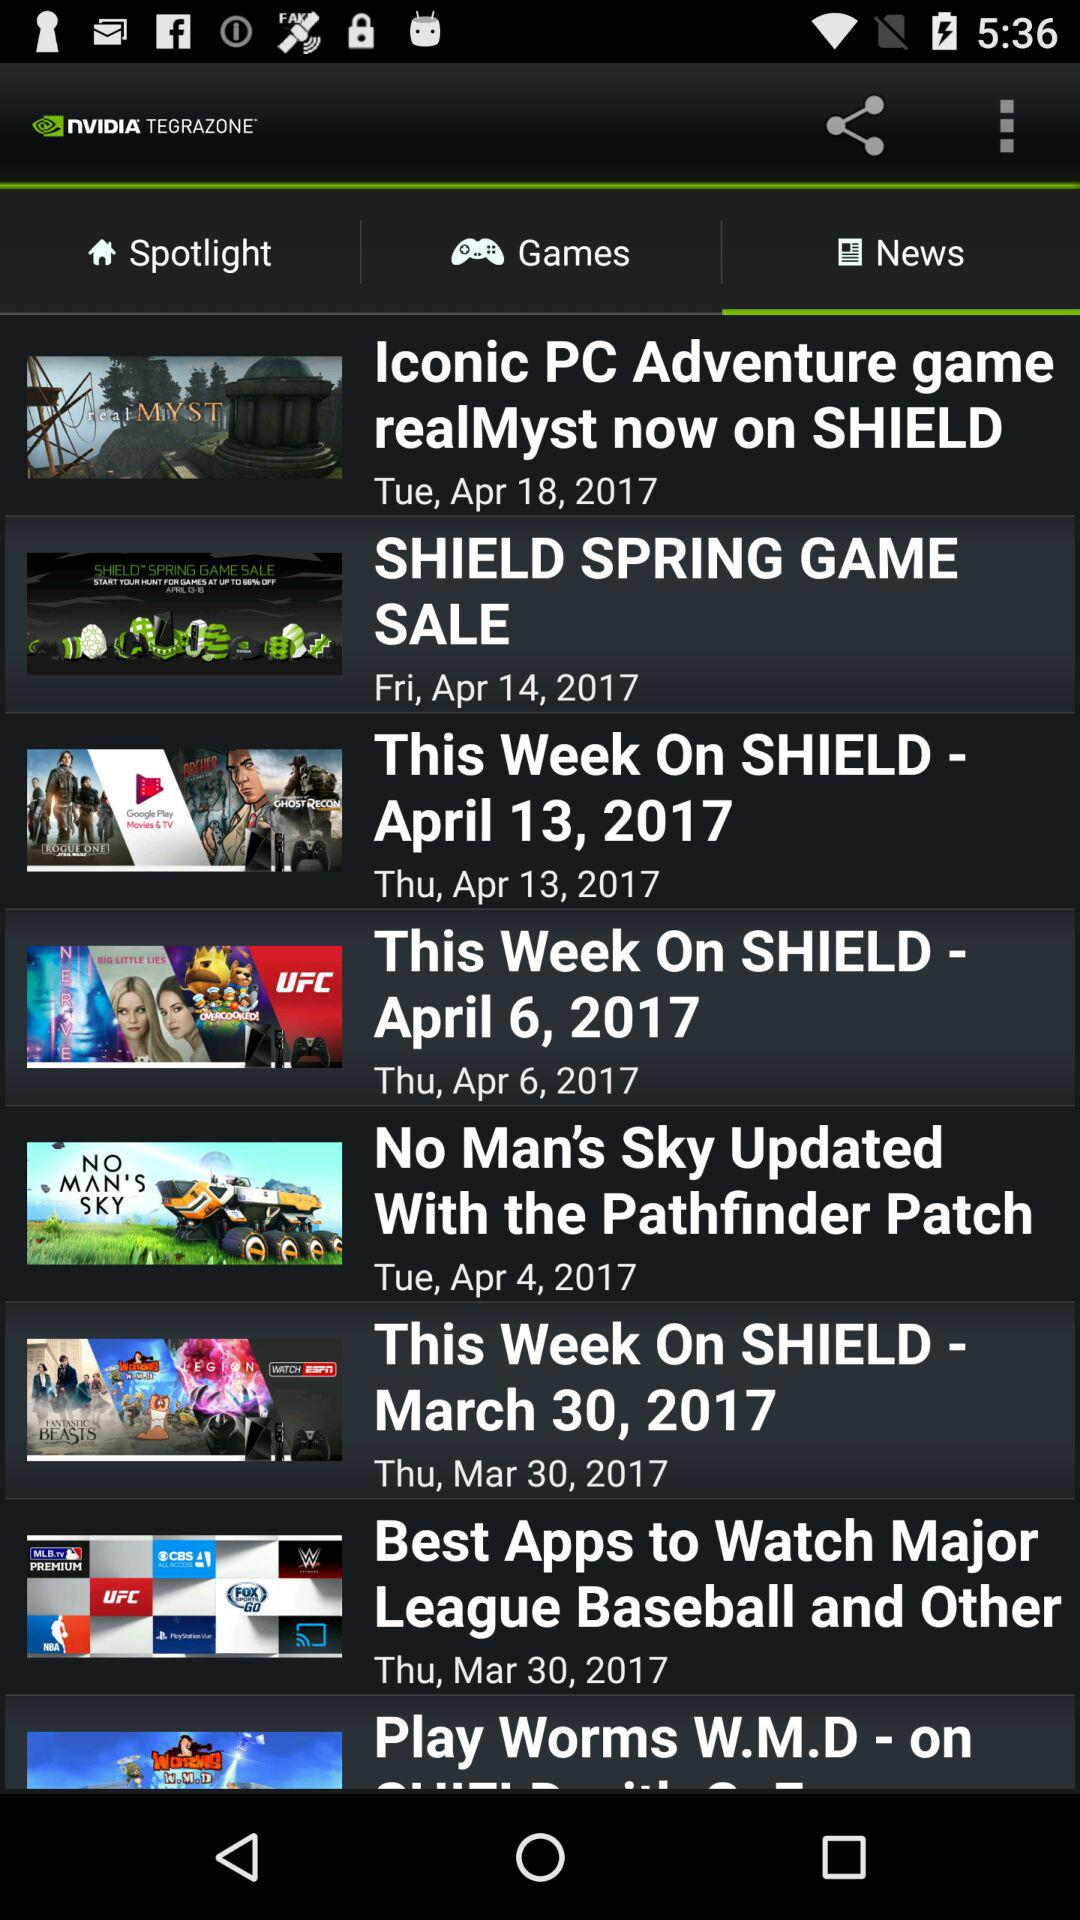What tab are we on? You are on the "News" tab. 